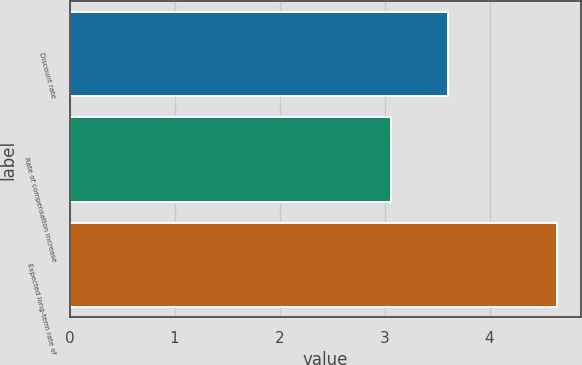Convert chart to OTSL. <chart><loc_0><loc_0><loc_500><loc_500><bar_chart><fcel>Discount rate<fcel>Rate of compensation increase<fcel>Expected long-term rate of<nl><fcel>3.6<fcel>3.06<fcel>4.64<nl></chart> 